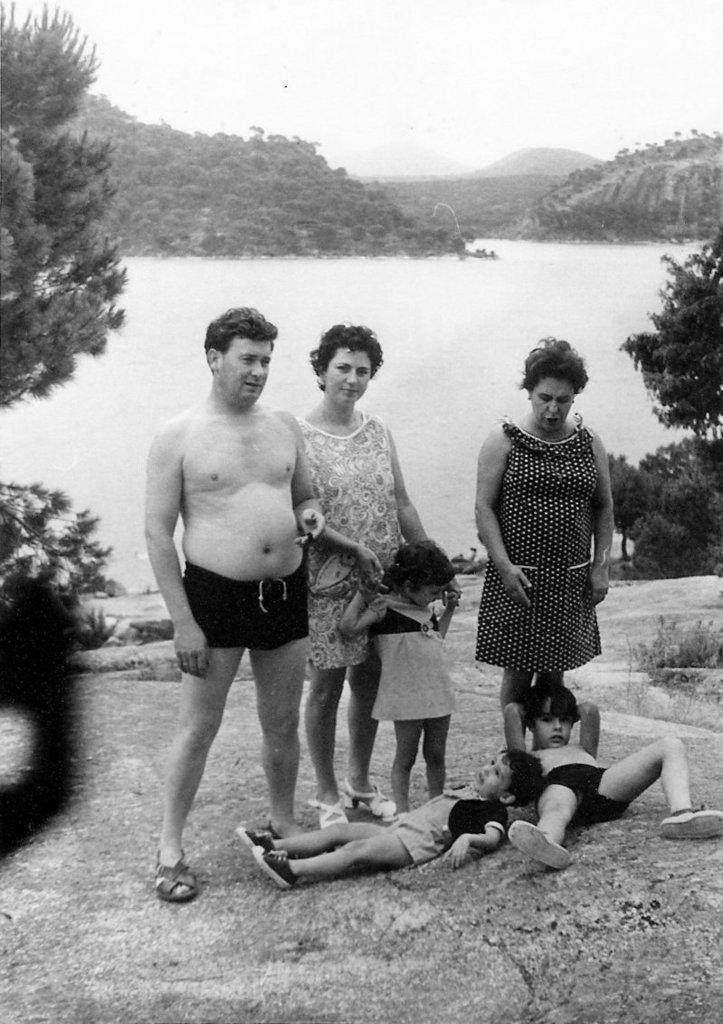What is the color scheme of the image? The image is black and white. Can you describe the people in the image? There are people in the image, but their specific actions or appearances are not mentioned in the facts. What is the terrain like in the image? The ground, plants, trees, water, and mountains are visible in the image, suggesting a natural landscape. What part of the sky is visible in the image? The sky is visible in the image, but the facts do not mention any specific weather conditions or celestial bodies. What type of gold jewelry can be seen on the people in the image? There is no mention of gold jewelry or any specific clothing or accessories in the image. How does the bread look like in the image? There is no bread present in the image. 